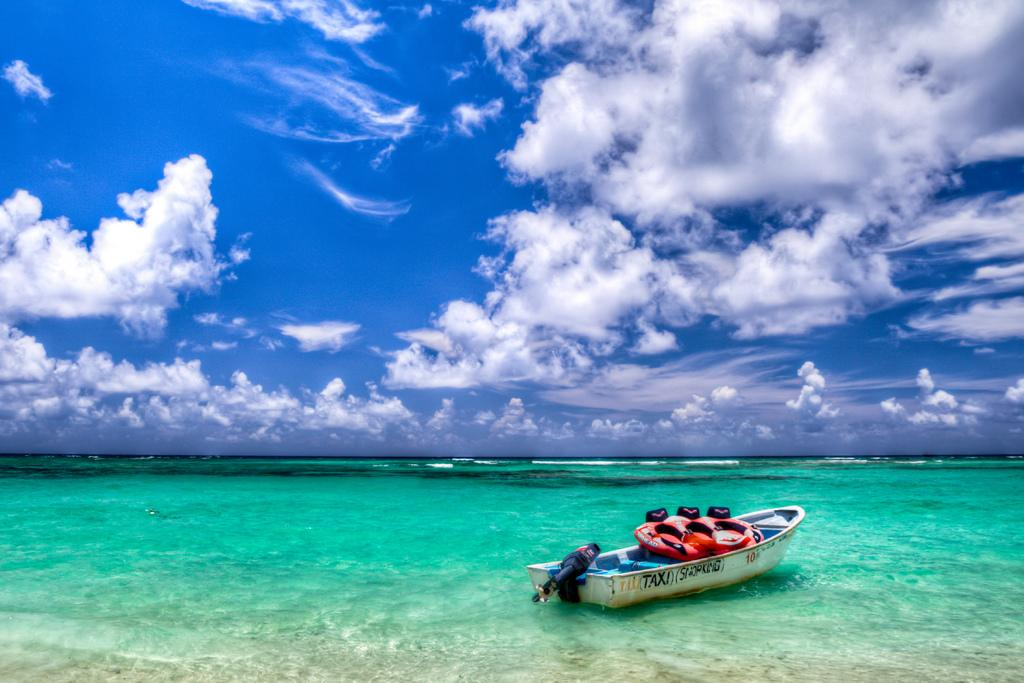Provide a one-sentence caption for the provided image. A boat with the words (Taxi) (Snorking) on the side sits in beautiful aqua blue water. 